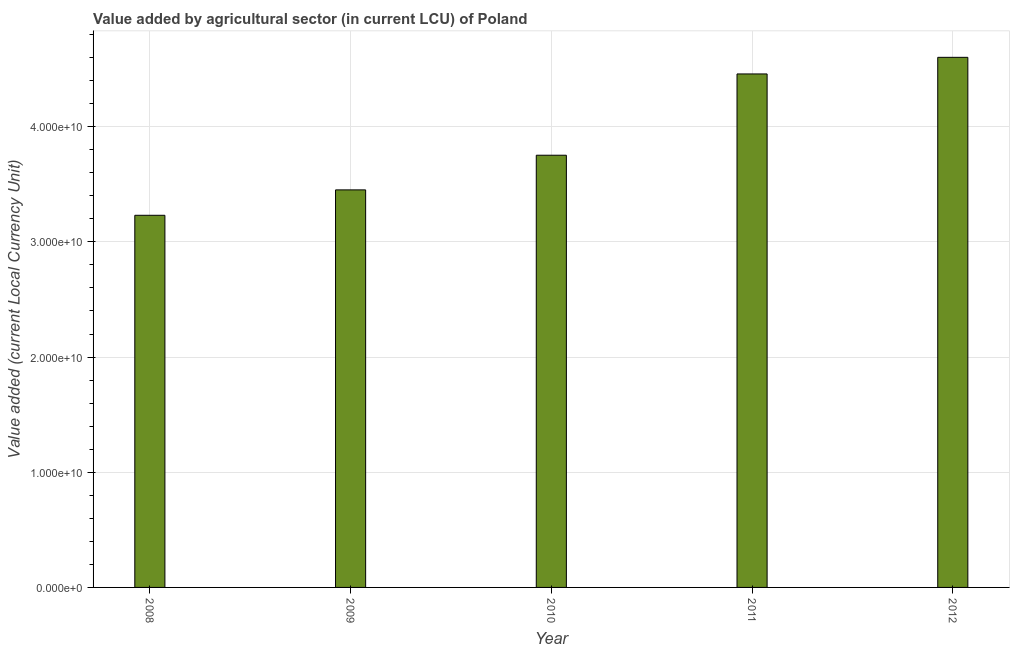Does the graph contain any zero values?
Ensure brevity in your answer.  No. What is the title of the graph?
Make the answer very short. Value added by agricultural sector (in current LCU) of Poland. What is the label or title of the Y-axis?
Offer a very short reply. Value added (current Local Currency Unit). What is the value added by agriculture sector in 2009?
Your response must be concise. 3.45e+1. Across all years, what is the maximum value added by agriculture sector?
Ensure brevity in your answer.  4.60e+1. Across all years, what is the minimum value added by agriculture sector?
Your answer should be compact. 3.23e+1. In which year was the value added by agriculture sector maximum?
Provide a short and direct response. 2012. In which year was the value added by agriculture sector minimum?
Offer a very short reply. 2008. What is the sum of the value added by agriculture sector?
Offer a terse response. 1.95e+11. What is the difference between the value added by agriculture sector in 2008 and 2011?
Provide a short and direct response. -1.23e+1. What is the average value added by agriculture sector per year?
Your answer should be compact. 3.90e+1. What is the median value added by agriculture sector?
Offer a terse response. 3.75e+1. What is the ratio of the value added by agriculture sector in 2008 to that in 2012?
Ensure brevity in your answer.  0.7. Is the value added by agriculture sector in 2010 less than that in 2012?
Your answer should be very brief. Yes. Is the difference between the value added by agriculture sector in 2009 and 2012 greater than the difference between any two years?
Offer a very short reply. No. What is the difference between the highest and the second highest value added by agriculture sector?
Offer a very short reply. 1.44e+09. Is the sum of the value added by agriculture sector in 2010 and 2012 greater than the maximum value added by agriculture sector across all years?
Offer a very short reply. Yes. What is the difference between the highest and the lowest value added by agriculture sector?
Offer a very short reply. 1.37e+1. How many bars are there?
Offer a terse response. 5. Are all the bars in the graph horizontal?
Your answer should be compact. No. How many years are there in the graph?
Offer a very short reply. 5. Are the values on the major ticks of Y-axis written in scientific E-notation?
Your response must be concise. Yes. What is the Value added (current Local Currency Unit) of 2008?
Keep it short and to the point. 3.23e+1. What is the Value added (current Local Currency Unit) in 2009?
Offer a very short reply. 3.45e+1. What is the Value added (current Local Currency Unit) in 2010?
Ensure brevity in your answer.  3.75e+1. What is the Value added (current Local Currency Unit) of 2011?
Offer a very short reply. 4.46e+1. What is the Value added (current Local Currency Unit) in 2012?
Your response must be concise. 4.60e+1. What is the difference between the Value added (current Local Currency Unit) in 2008 and 2009?
Provide a succinct answer. -2.21e+09. What is the difference between the Value added (current Local Currency Unit) in 2008 and 2010?
Offer a very short reply. -5.21e+09. What is the difference between the Value added (current Local Currency Unit) in 2008 and 2011?
Provide a succinct answer. -1.23e+1. What is the difference between the Value added (current Local Currency Unit) in 2008 and 2012?
Offer a terse response. -1.37e+1. What is the difference between the Value added (current Local Currency Unit) in 2009 and 2010?
Your answer should be compact. -3.01e+09. What is the difference between the Value added (current Local Currency Unit) in 2009 and 2011?
Offer a very short reply. -1.01e+1. What is the difference between the Value added (current Local Currency Unit) in 2009 and 2012?
Provide a short and direct response. -1.15e+1. What is the difference between the Value added (current Local Currency Unit) in 2010 and 2011?
Your response must be concise. -7.06e+09. What is the difference between the Value added (current Local Currency Unit) in 2010 and 2012?
Your answer should be very brief. -8.50e+09. What is the difference between the Value added (current Local Currency Unit) in 2011 and 2012?
Offer a very short reply. -1.44e+09. What is the ratio of the Value added (current Local Currency Unit) in 2008 to that in 2009?
Your answer should be compact. 0.94. What is the ratio of the Value added (current Local Currency Unit) in 2008 to that in 2010?
Offer a terse response. 0.86. What is the ratio of the Value added (current Local Currency Unit) in 2008 to that in 2011?
Give a very brief answer. 0.72. What is the ratio of the Value added (current Local Currency Unit) in 2008 to that in 2012?
Your answer should be very brief. 0.7. What is the ratio of the Value added (current Local Currency Unit) in 2009 to that in 2011?
Keep it short and to the point. 0.77. What is the ratio of the Value added (current Local Currency Unit) in 2009 to that in 2012?
Keep it short and to the point. 0.75. What is the ratio of the Value added (current Local Currency Unit) in 2010 to that in 2011?
Your response must be concise. 0.84. What is the ratio of the Value added (current Local Currency Unit) in 2010 to that in 2012?
Offer a terse response. 0.81. What is the ratio of the Value added (current Local Currency Unit) in 2011 to that in 2012?
Your answer should be compact. 0.97. 